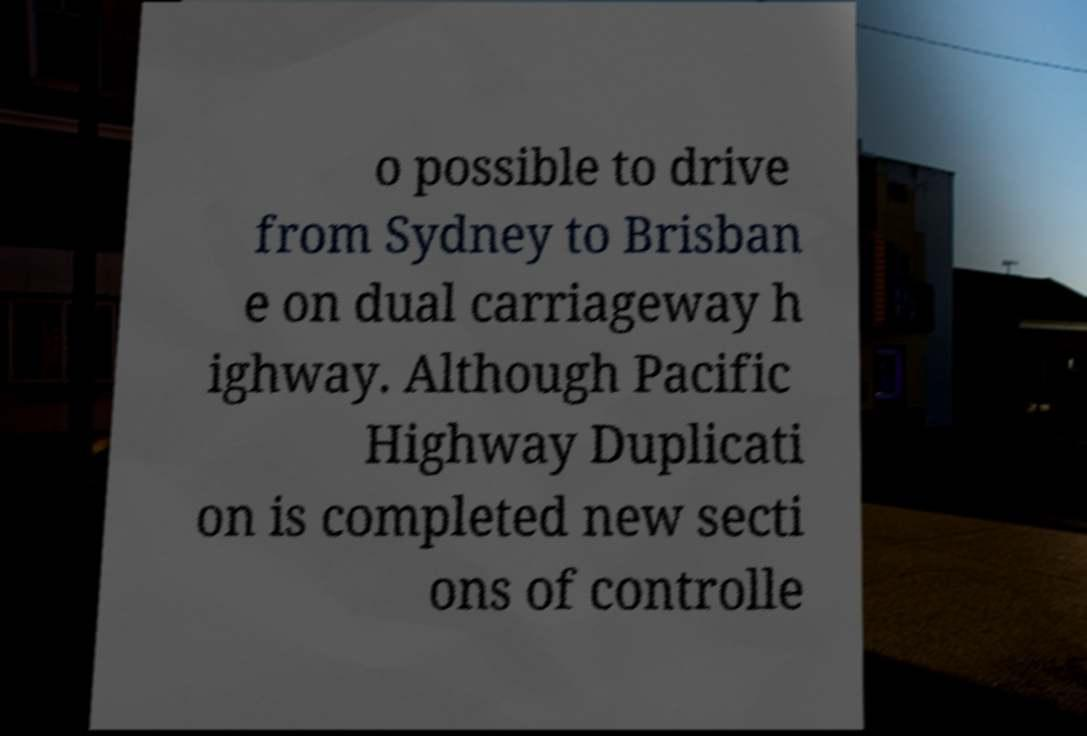Could you assist in decoding the text presented in this image and type it out clearly? o possible to drive from Sydney to Brisban e on dual carriageway h ighway. Although Pacific Highway Duplicati on is completed new secti ons of controlle 